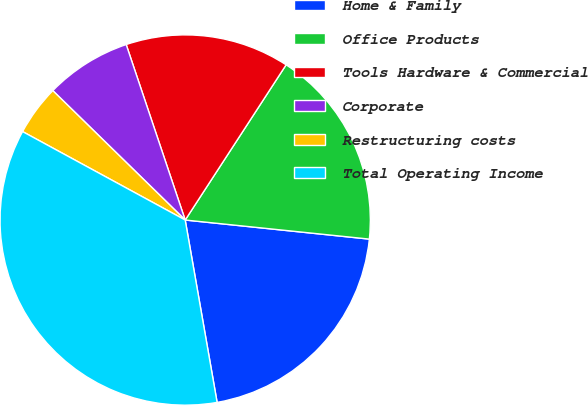Convert chart to OTSL. <chart><loc_0><loc_0><loc_500><loc_500><pie_chart><fcel>Home & Family<fcel>Office Products<fcel>Tools Hardware & Commercial<fcel>Corporate<fcel>Restructuring costs<fcel>Total Operating Income<nl><fcel>20.6%<fcel>17.47%<fcel>14.34%<fcel>7.52%<fcel>4.39%<fcel>35.69%<nl></chart> 